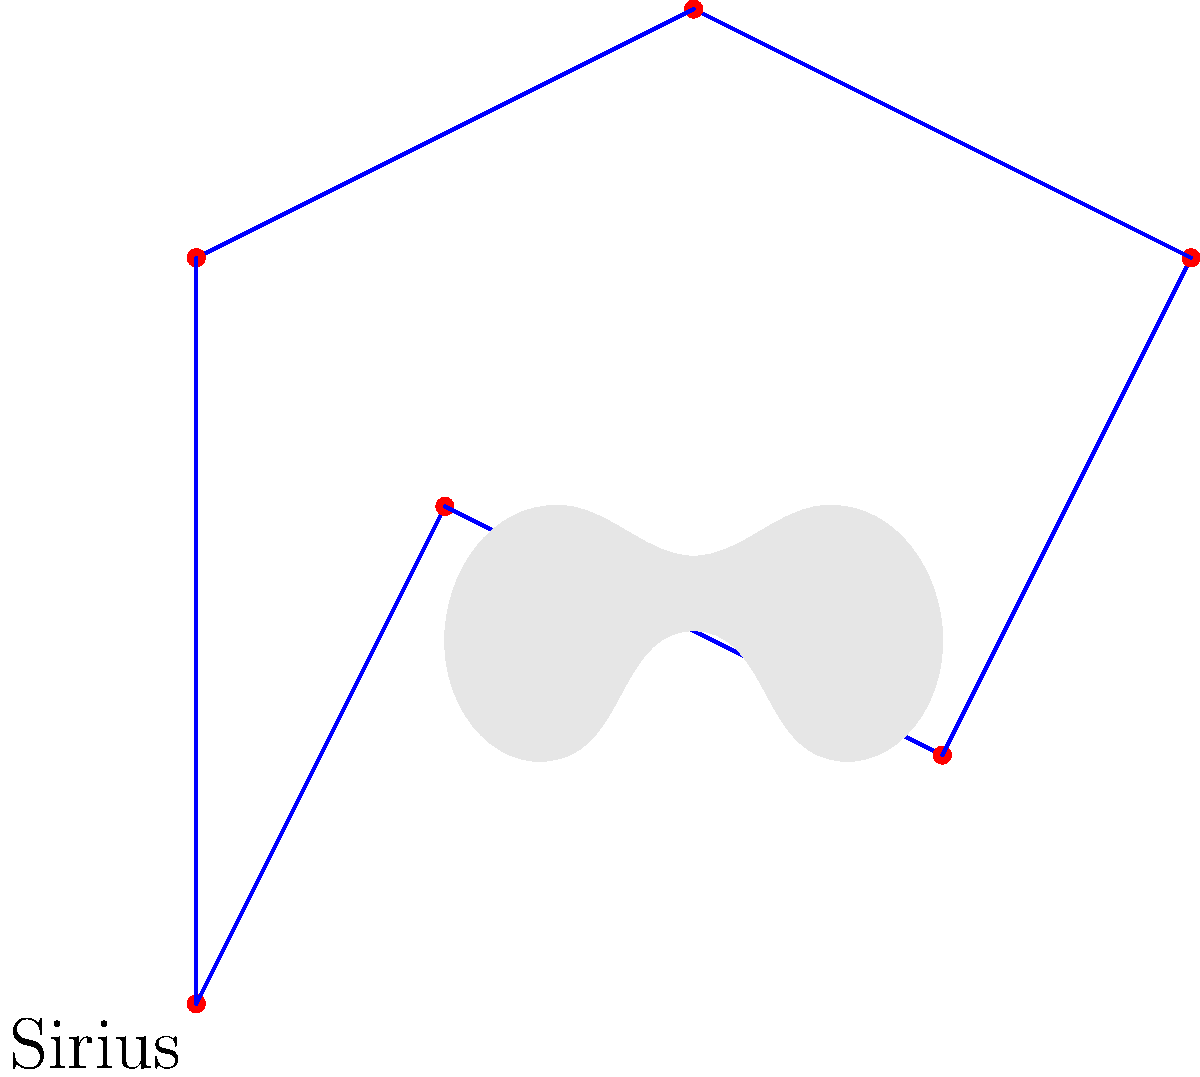In the constellation Canis Major, which represents a dog in the night sky, there's a particularly bright star that might catch your eye just like your furry friend does. This star, located at the "chest" of the celestial dog, is the brightest star in the night sky. Can you identify this star's name? To answer this question, let's break it down step-by-step:

1. Canis Major is a constellation visible in the night sky, often depicted as a large dog.

2. The question mentions a particularly bright star in this constellation, located at the "chest" of the celestial dog.

3. It's stated that this star is the brightest star in the night sky.

4. In astronomy, the brightest star in the night sky is well-known to be Sirius.

5. Sirius is indeed part of the Canis Major constellation, and its position in the constellation is typically represented at the dog's chest or neck area.

6. The name "Sirius" comes from the Greek word "seirios," meaning "scorching" or "glowing," which is fitting for such a bright star.

7. Sirius is also sometimes called the "Dog Star" because of its position in Canis Major, which aligns perfectly with the dog-loving theme of the question.

Therefore, the bright star being referred to in the question is Sirius.
Answer: Sirius 